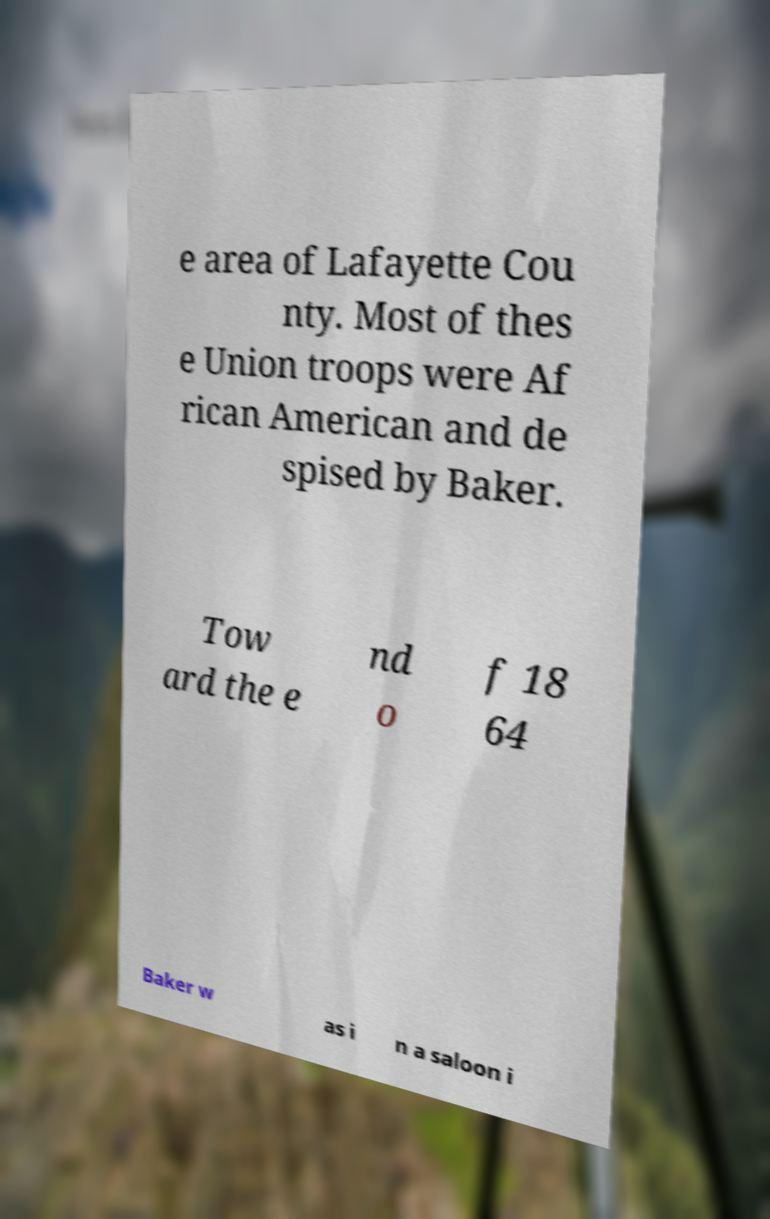Please identify and transcribe the text found in this image. e area of Lafayette Cou nty. Most of thes e Union troops were Af rican American and de spised by Baker. Tow ard the e nd o f 18 64 Baker w as i n a saloon i 